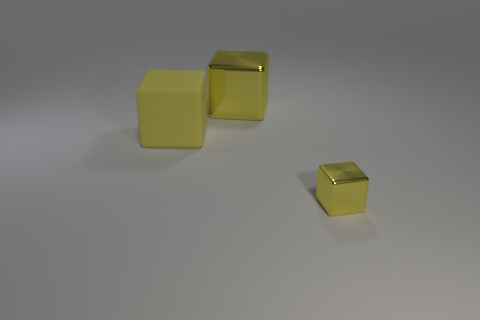Subtract all blue cubes. Subtract all gray cylinders. How many cubes are left? 3 Add 1 large brown matte spheres. How many objects exist? 4 Subtract all big purple rubber things. Subtract all tiny yellow metallic cubes. How many objects are left? 2 Add 1 big yellow shiny things. How many big yellow shiny things are left? 2 Add 2 yellow metal cubes. How many yellow metal cubes exist? 4 Subtract 0 brown cubes. How many objects are left? 3 